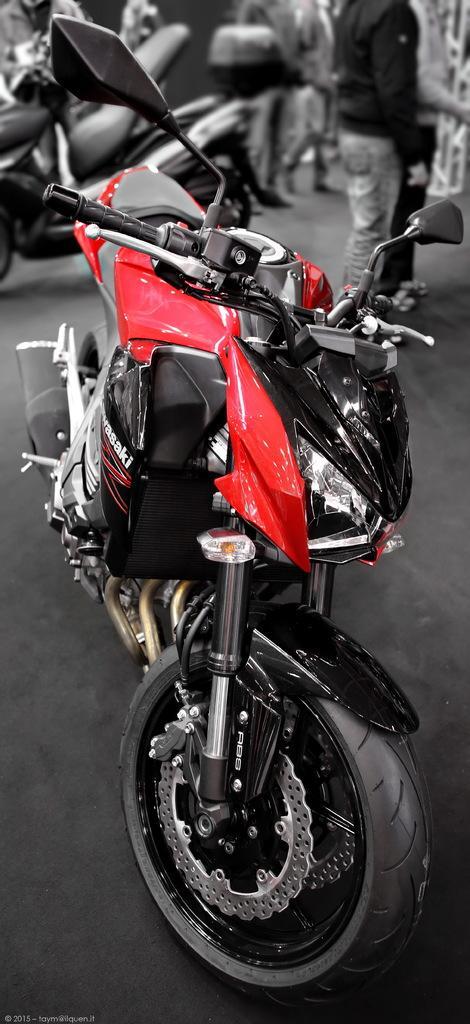Could you give a brief overview of what you see in this image? In this image there are bikes and there are persons. In the background on the right side there is an object which is white in colour. 